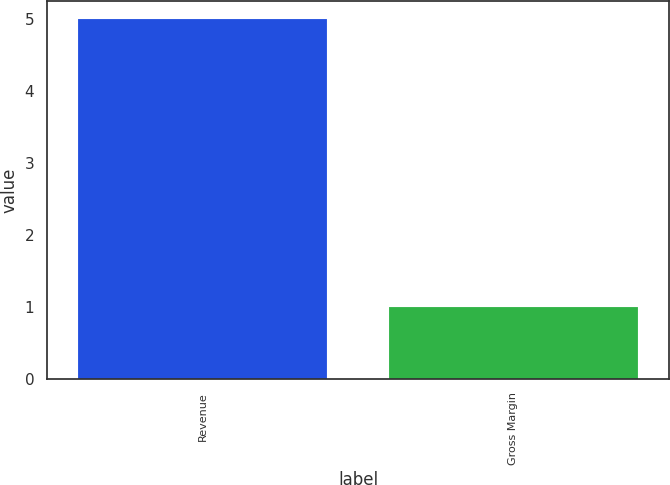<chart> <loc_0><loc_0><loc_500><loc_500><bar_chart><fcel>Revenue<fcel>Gross Margin<nl><fcel>5<fcel>1<nl></chart> 